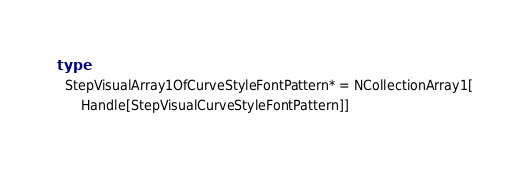Convert code to text. <code><loc_0><loc_0><loc_500><loc_500><_Nim_>type
  StepVisualArray1OfCurveStyleFontPattern* = NCollectionArray1[
      Handle[StepVisualCurveStyleFontPattern]]
</code> 